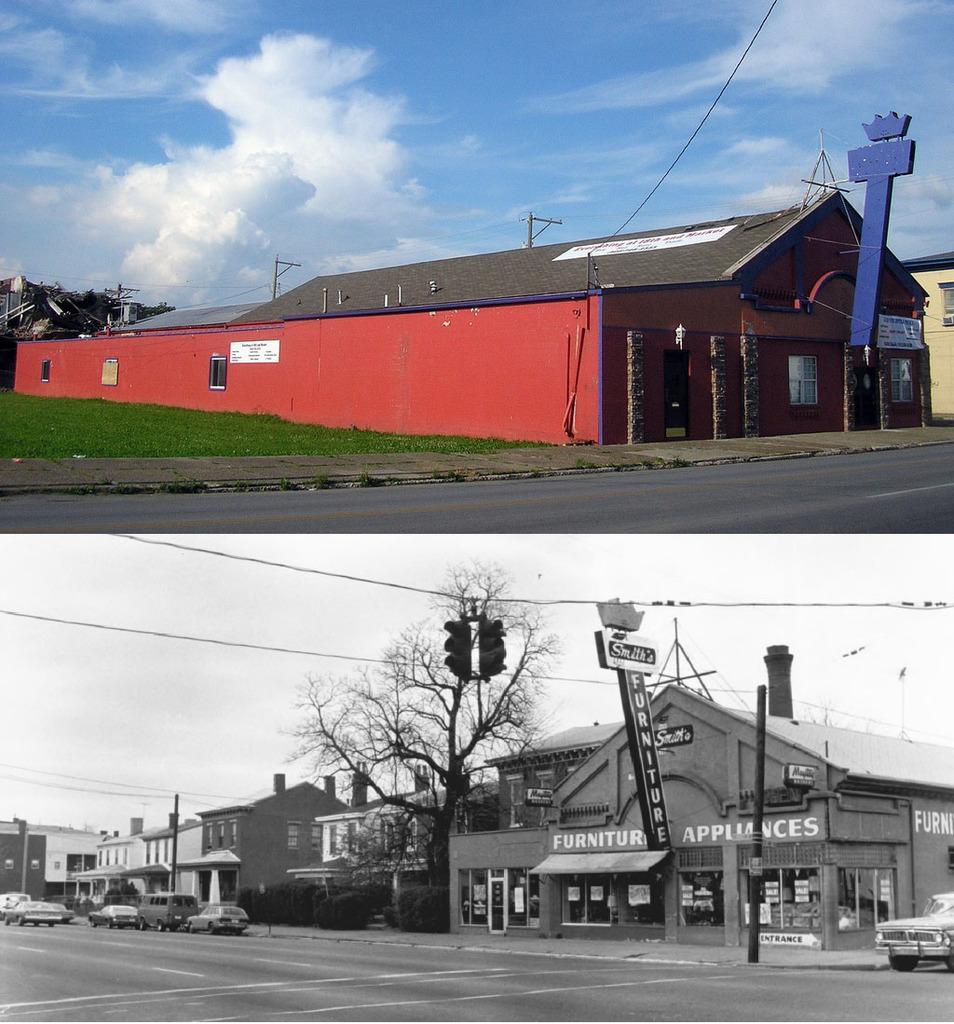Can you describe this image briefly? In the picture we can see two images, in the in the first image we can see a huge shed and near it, we can see a grass surface and a road and in the second image we can see a road on it, we can see some vehicles near the path and behind it, we can see some buildings with windows and glasses to it and near to the houses we can see a tree and it is a black and white image. 